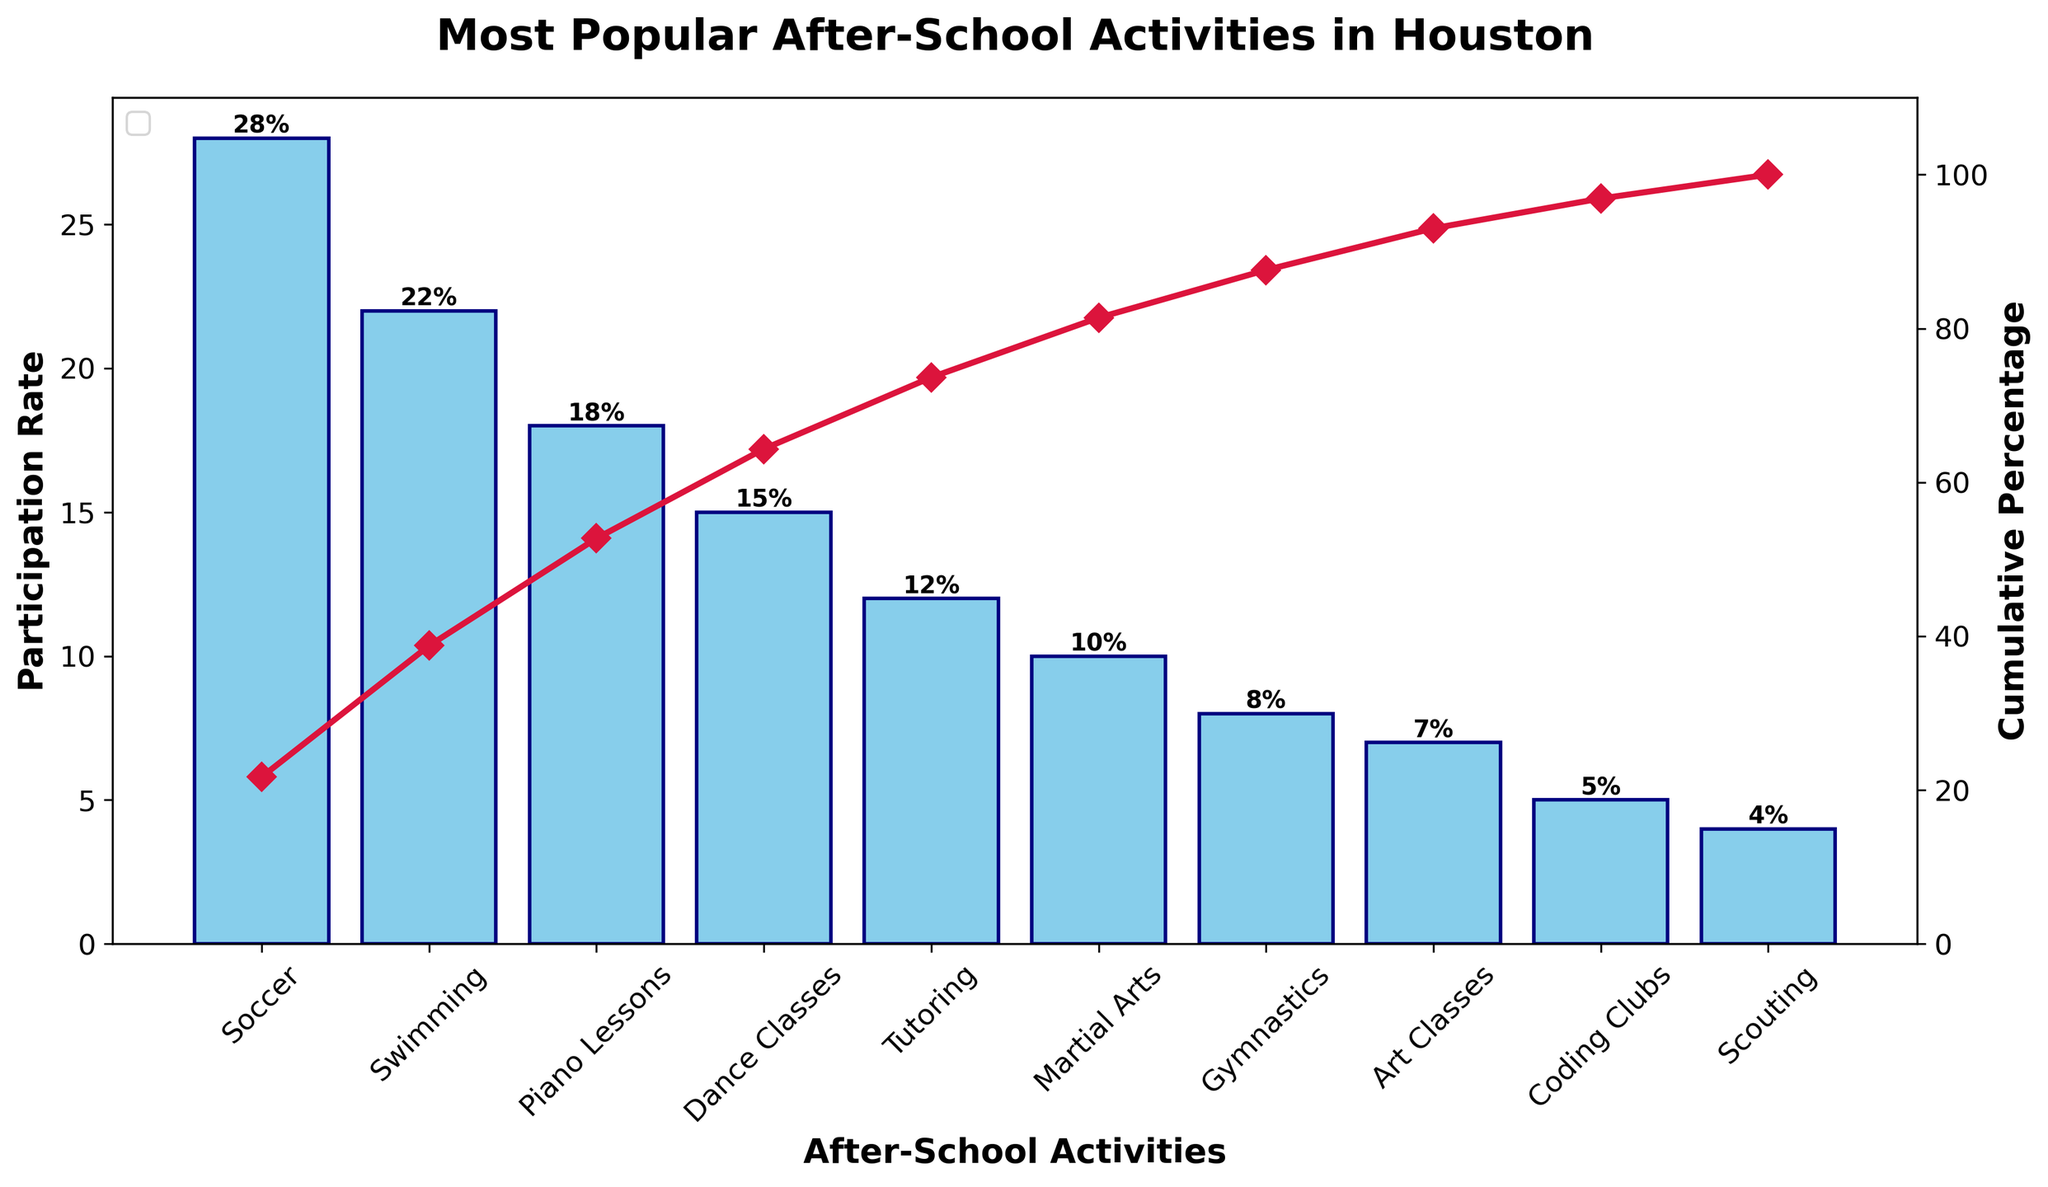What's the title of the figure? The figure's title is located at the top and indicates what the chart is about. From the figure, we can see it says "Most Popular After-School Activities in Houston".
Answer: Most Popular After-School Activities in Houston What's the activity with the highest participation rate? To find this, look at the tallest bar on the bar chart, which represents the activity with the highest participation rate. According to the chart, Soccer has the tallest bar at 28%.
Answer: Soccer Which activity has the lowest participation rate? The activity with the lowest participation rate is represented by the shortest bar in the chart. Scouting has the shortest bar with a participation rate of 4%.
Answer: Scouting What is the cumulative percentage for the top three activities? The cumulative percentage is represented by the line plot. The cumulative percentage for the top three activities (Soccer, Swimming, Piano Lessons) can be found by adding their participation rates and then confirming from the line plot. So, 28% (Soccer) + 22% (Swimming) + 18% (Piano Lessons) = 68%.
Answer: 68% How many activities have a participation rate of 10% or higher? This can be determined by counting the bars that have a height of 10% or more. The activities are Soccer (28%), Swimming (22%), Piano Lessons (18%), Dance Classes (15%), and Tutoring (12%), and Martial Arts (10%). There are 6 such activities.
Answer: 6 What is the cumulative percentage after Art Classes? The cumulative percentage is shown by the line plot. We sum the participation rates up to and including Art Classes: 28% (Soccer) + 22% (Swimming) + 18% (Piano Lessons) + 15% (Dance Classes) + 12% (Tutoring) + 10% (Martial Arts) + 8% (Gymnastics) + 7% (Art Classes) = 120%.
Answer: 120% By how much does the participation rate of Swimming surpass Gymnastics? We subtract the participation rate of Gymnastics from Swimming. Swimming is 22%, while Gymnastics is 8%. So the difference is 22% - 8% = 14%.
Answer: 14% What is the cumulative percentage when adding Coding Clubs’ participation rate to the previous cumulative percentage? First, find the cumulative percentage before Coding Clubs and then add the participation rate of Coding Clubs. The cumulative percentage before Coding Clubs includes up to Art Classes, which is 120%. Adding Coding Clubs (5%) gives us 120% + 5% = 125%.
Answer: 125% What percentage of total participation do the activities Dance Classes and Tutoring represent together? Add the participation rates of Dance Classes and Tutoring: 15% + 12% = 27%.
Answer: 27% How many activities have a lower participation rate than Dance Classes? Count the activities with bars shorter than Dance Classes' bar (15%). These are Tutoring (12%), Martial Arts (10%), Gymnastics (8%), Art Classes (7%), Coding Clubs (5%), and Scouting (4%). There are 6 such activities.
Answer: 6 